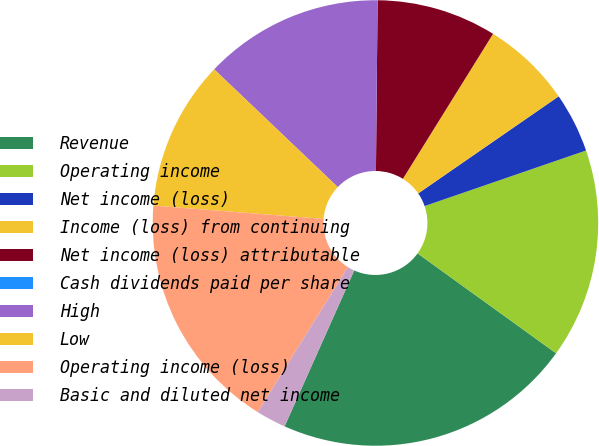<chart> <loc_0><loc_0><loc_500><loc_500><pie_chart><fcel>Revenue<fcel>Operating income<fcel>Net income (loss)<fcel>Income (loss) from continuing<fcel>Net income (loss) attributable<fcel>Cash dividends paid per share<fcel>High<fcel>Low<fcel>Operating income (loss)<fcel>Basic and diluted net income<nl><fcel>21.74%<fcel>15.22%<fcel>4.35%<fcel>6.52%<fcel>8.7%<fcel>0.0%<fcel>13.04%<fcel>10.87%<fcel>17.39%<fcel>2.17%<nl></chart> 